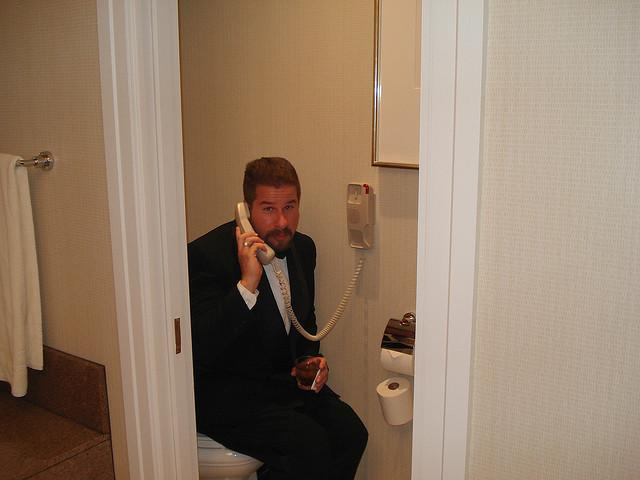What is he doing? Please explain your reasoning. speaking phone. The man is sitting on the toilet seat and talking on the telephone. 